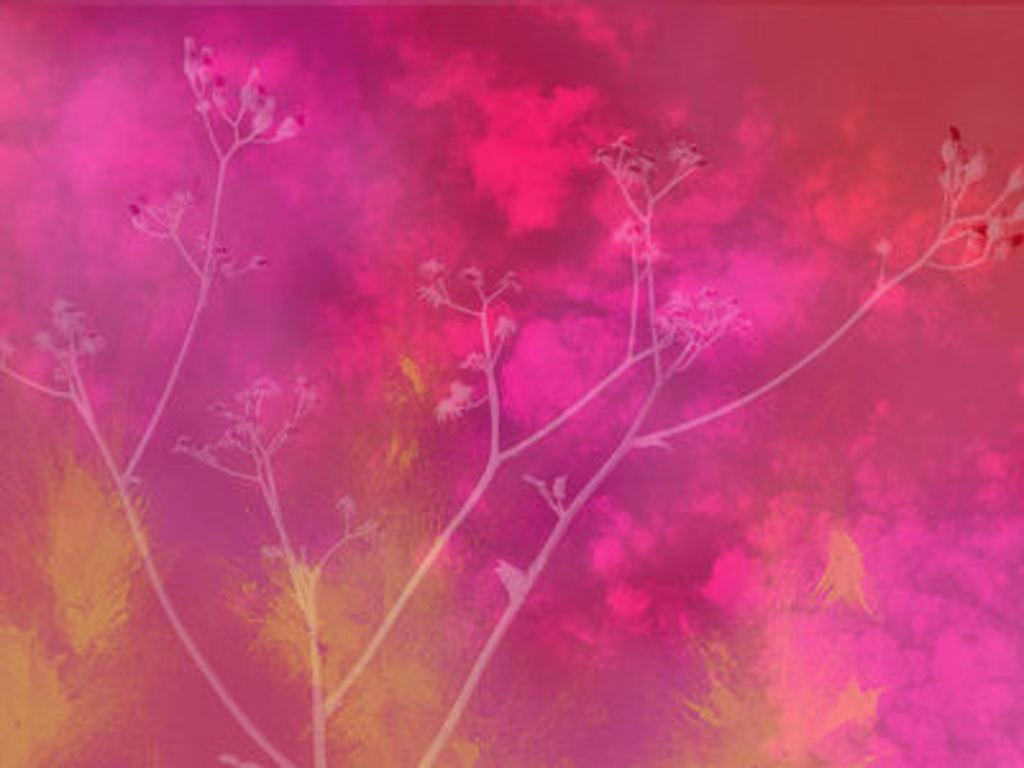What type of tree is present in the image? There is a tree with flowers in the image. What colors can be seen in the background of the image? The background has red, pink, and yellow colors. Can you tell if the image has been edited or altered in any way? The image might be edited, but it cannot be definitively determined from the provided facts. Where is the fork hanging from the tree in the image? There is no fork present in the image; it only features a tree with flowers and a background with red, pink, and yellow colors. 